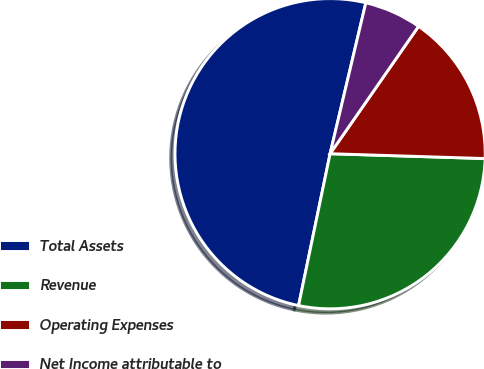Convert chart to OTSL. <chart><loc_0><loc_0><loc_500><loc_500><pie_chart><fcel>Total Assets<fcel>Revenue<fcel>Operating Expenses<fcel>Net Income attributable to<nl><fcel>50.44%<fcel>27.76%<fcel>15.84%<fcel>5.96%<nl></chart> 